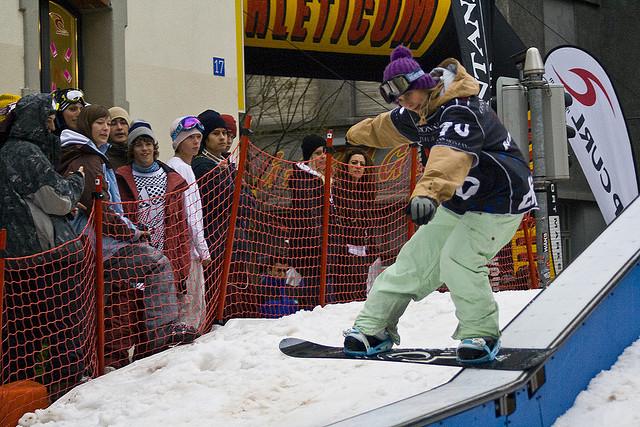What is the boy riding?
Be succinct. Snowboard. What color is the banner?
Concise answer only. Yellow. What color is the man's helmet?
Quick response, please. Purple. What does the red sign say?
Be succinct. Aleuticum. Is the snowboarder going up or down hill?
Give a very brief answer. Down. Is he wearing jeans?
Give a very brief answer. No. What is the name of the event?
Be succinct. Snowboarding. What is the man riding on?
Concise answer only. Snowboard. How many infants are in the crowd?
Quick response, please. 0. Is this scene outside?
Be succinct. Yes. What is the name of the trick being performed in this photo?
Answer briefly. Boardslide. 